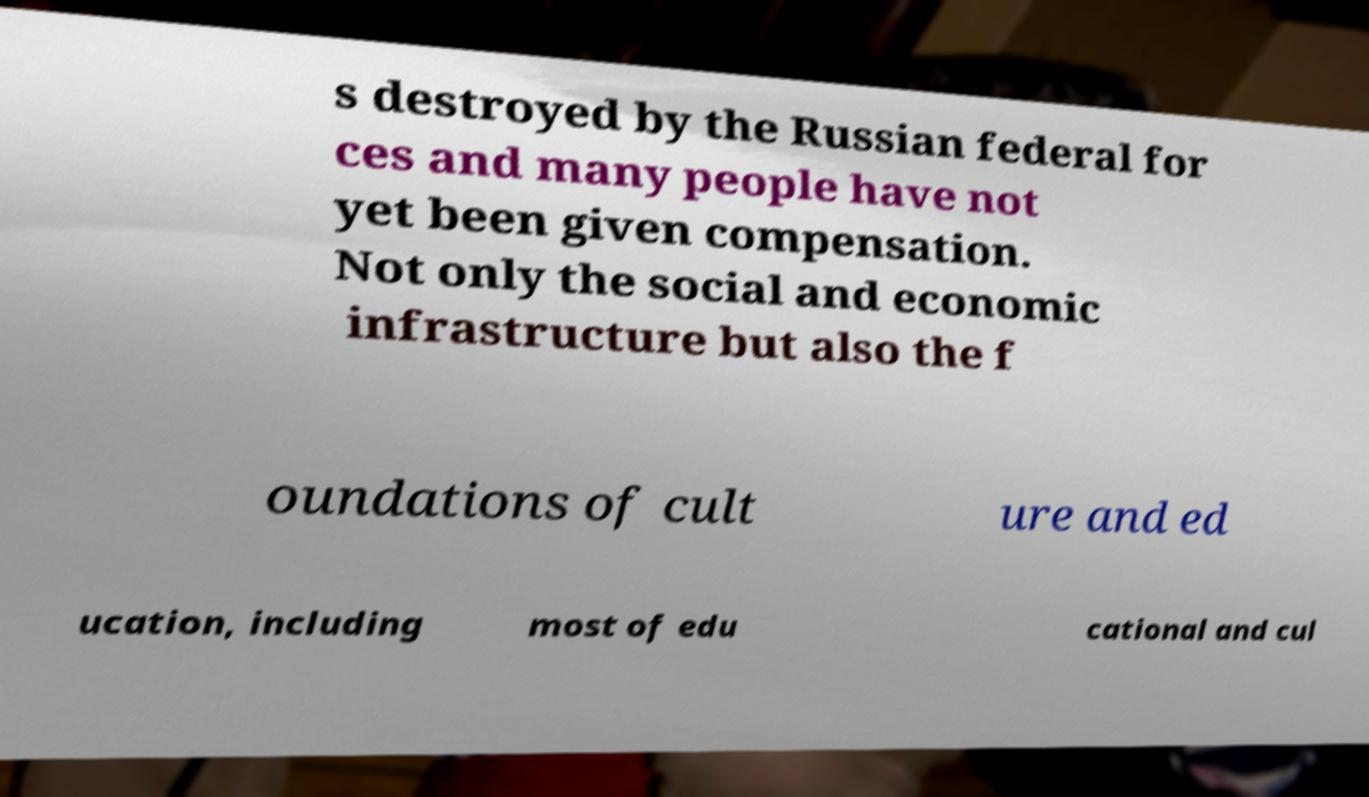What messages or text are displayed in this image? I need them in a readable, typed format. s destroyed by the Russian federal for ces and many people have not yet been given compensation. Not only the social and economic infrastructure but also the f oundations of cult ure and ed ucation, including most of edu cational and cul 